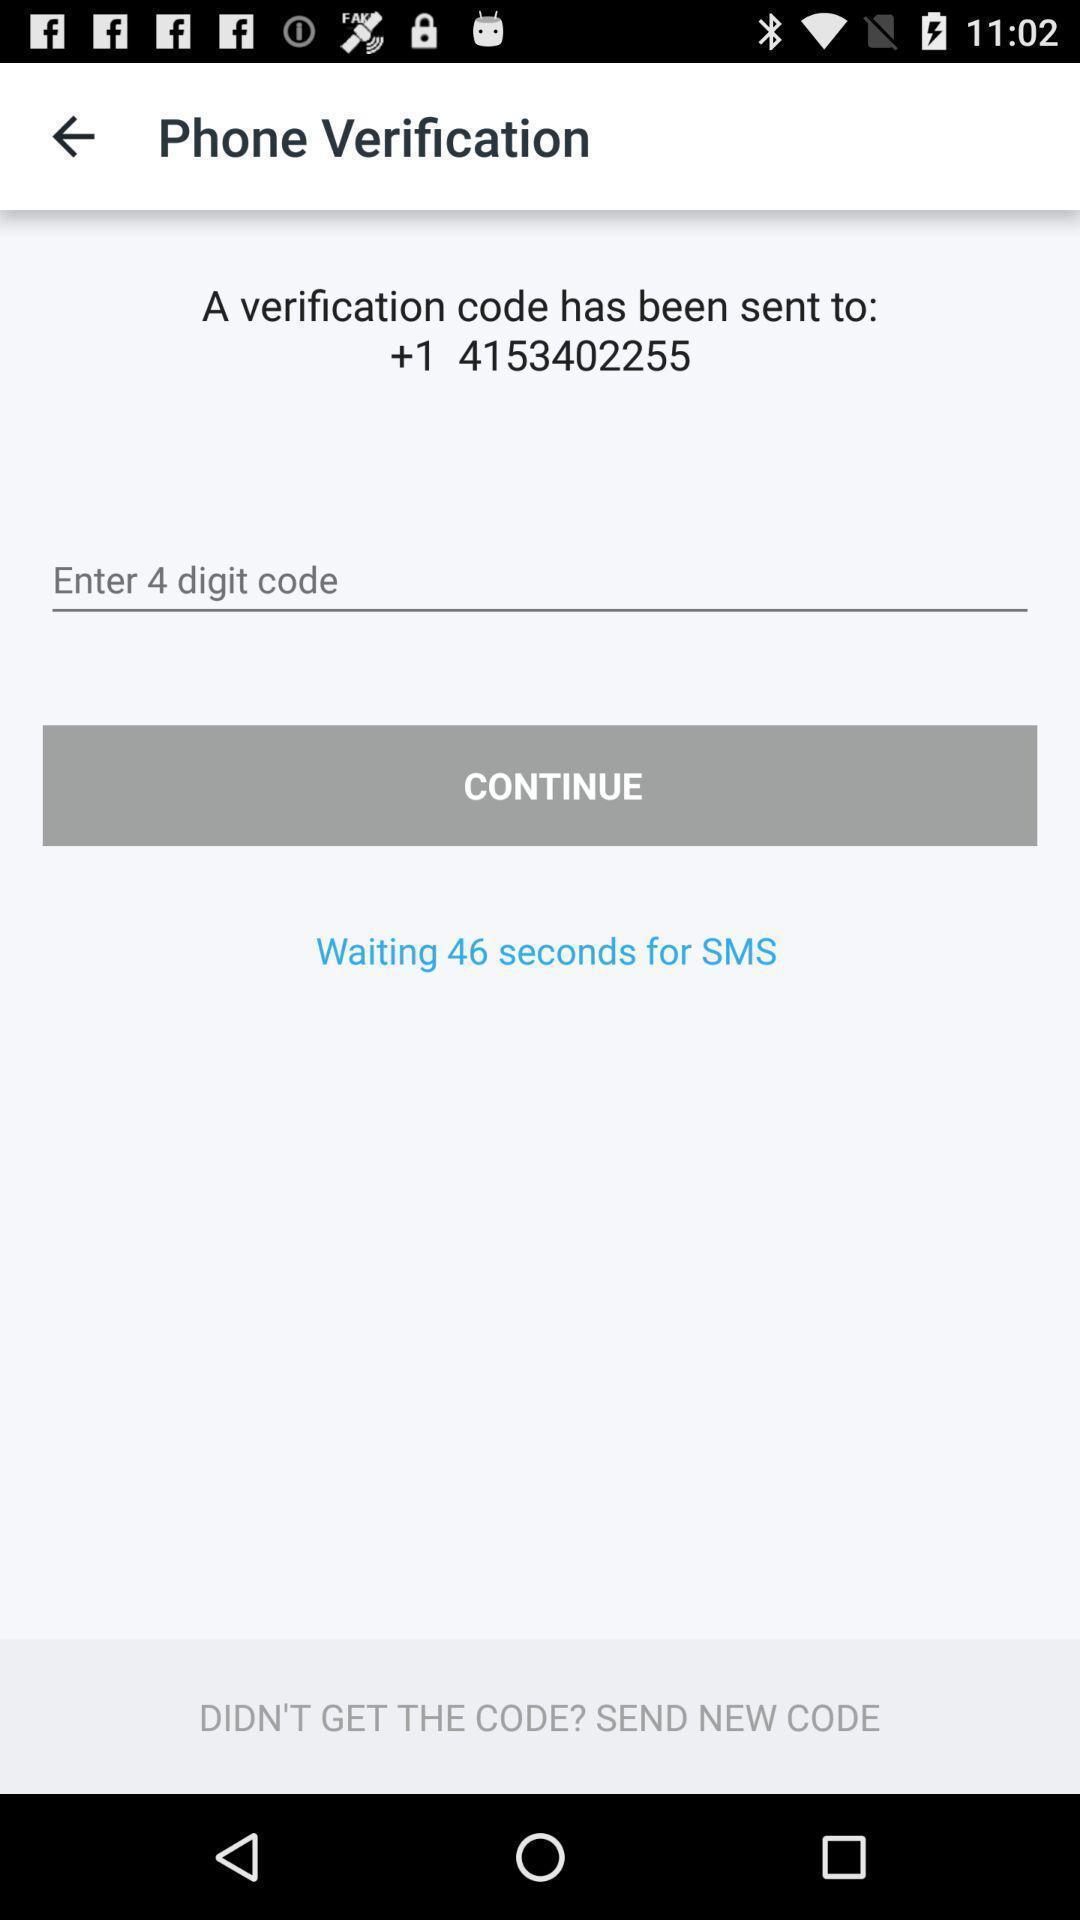What can you discern from this picture? Verification page. 